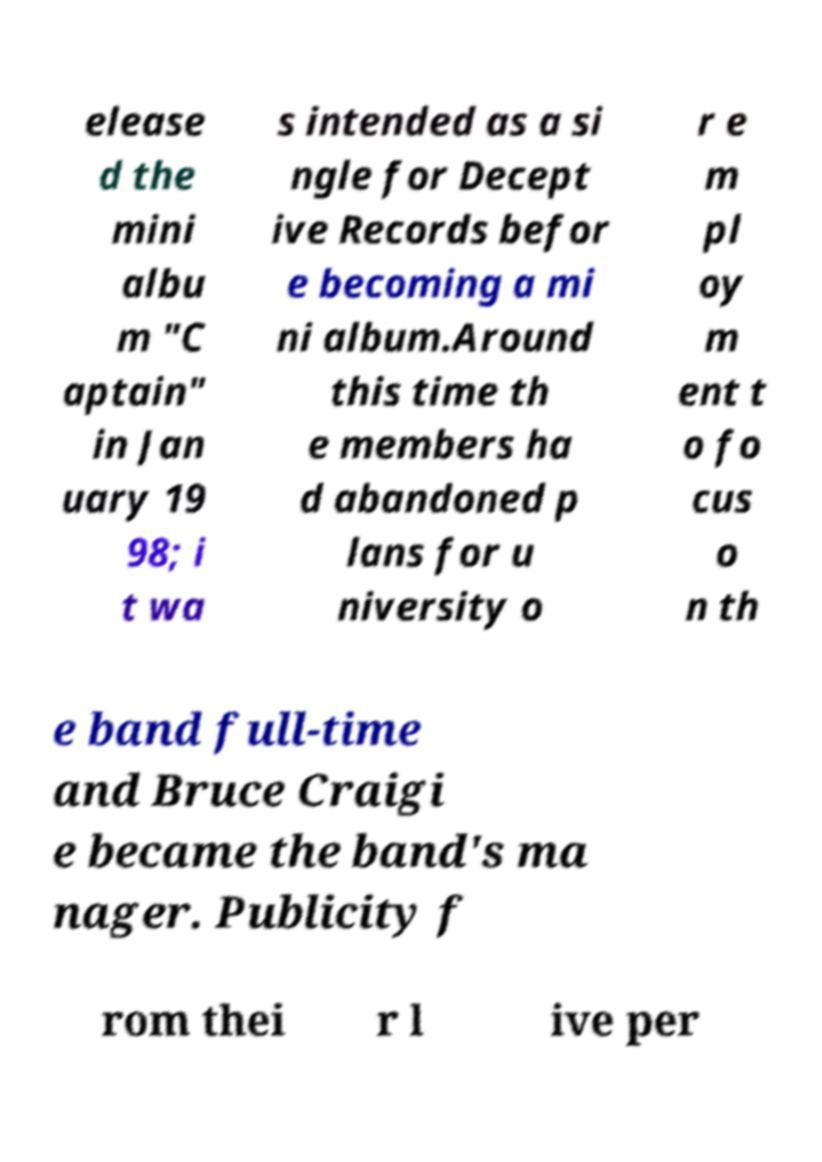Could you assist in decoding the text presented in this image and type it out clearly? elease d the mini albu m "C aptain" in Jan uary 19 98; i t wa s intended as a si ngle for Decept ive Records befor e becoming a mi ni album.Around this time th e members ha d abandoned p lans for u niversity o r e m pl oy m ent t o fo cus o n th e band full-time and Bruce Craigi e became the band's ma nager. Publicity f rom thei r l ive per 